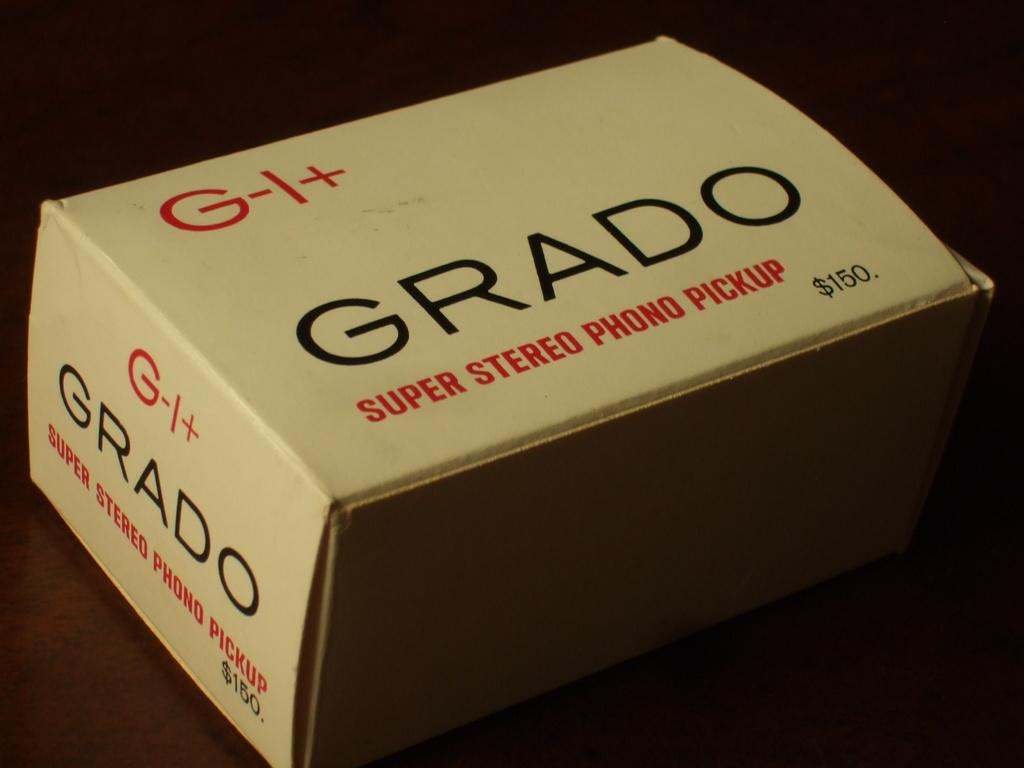<image>
Create a compact narrative representing the image presented. Box labeld GRADO SUPER STEREO PHONO PICKUP price is $150. 